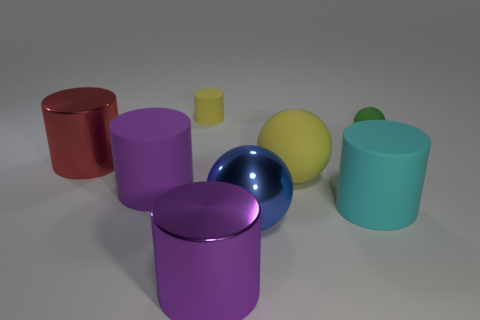Subtract all big purple matte cylinders. How many cylinders are left? 4 Subtract all yellow cylinders. How many cylinders are left? 4 Subtract all gray cylinders. Subtract all blue cubes. How many cylinders are left? 5 Add 2 cylinders. How many objects exist? 10 Subtract all cylinders. How many objects are left? 3 Add 5 cyan cylinders. How many cyan cylinders are left? 6 Add 6 green matte blocks. How many green matte blocks exist? 6 Subtract 1 yellow balls. How many objects are left? 7 Subtract all rubber cubes. Subtract all tiny green balls. How many objects are left? 7 